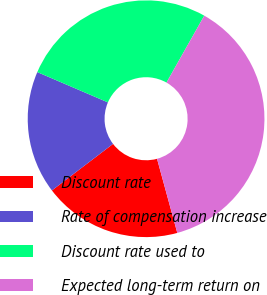Convert chart to OTSL. <chart><loc_0><loc_0><loc_500><loc_500><pie_chart><fcel>Discount rate<fcel>Rate of compensation increase<fcel>Discount rate used to<fcel>Expected long-term return on<nl><fcel>18.89%<fcel>16.8%<fcel>26.73%<fcel>37.57%<nl></chart> 